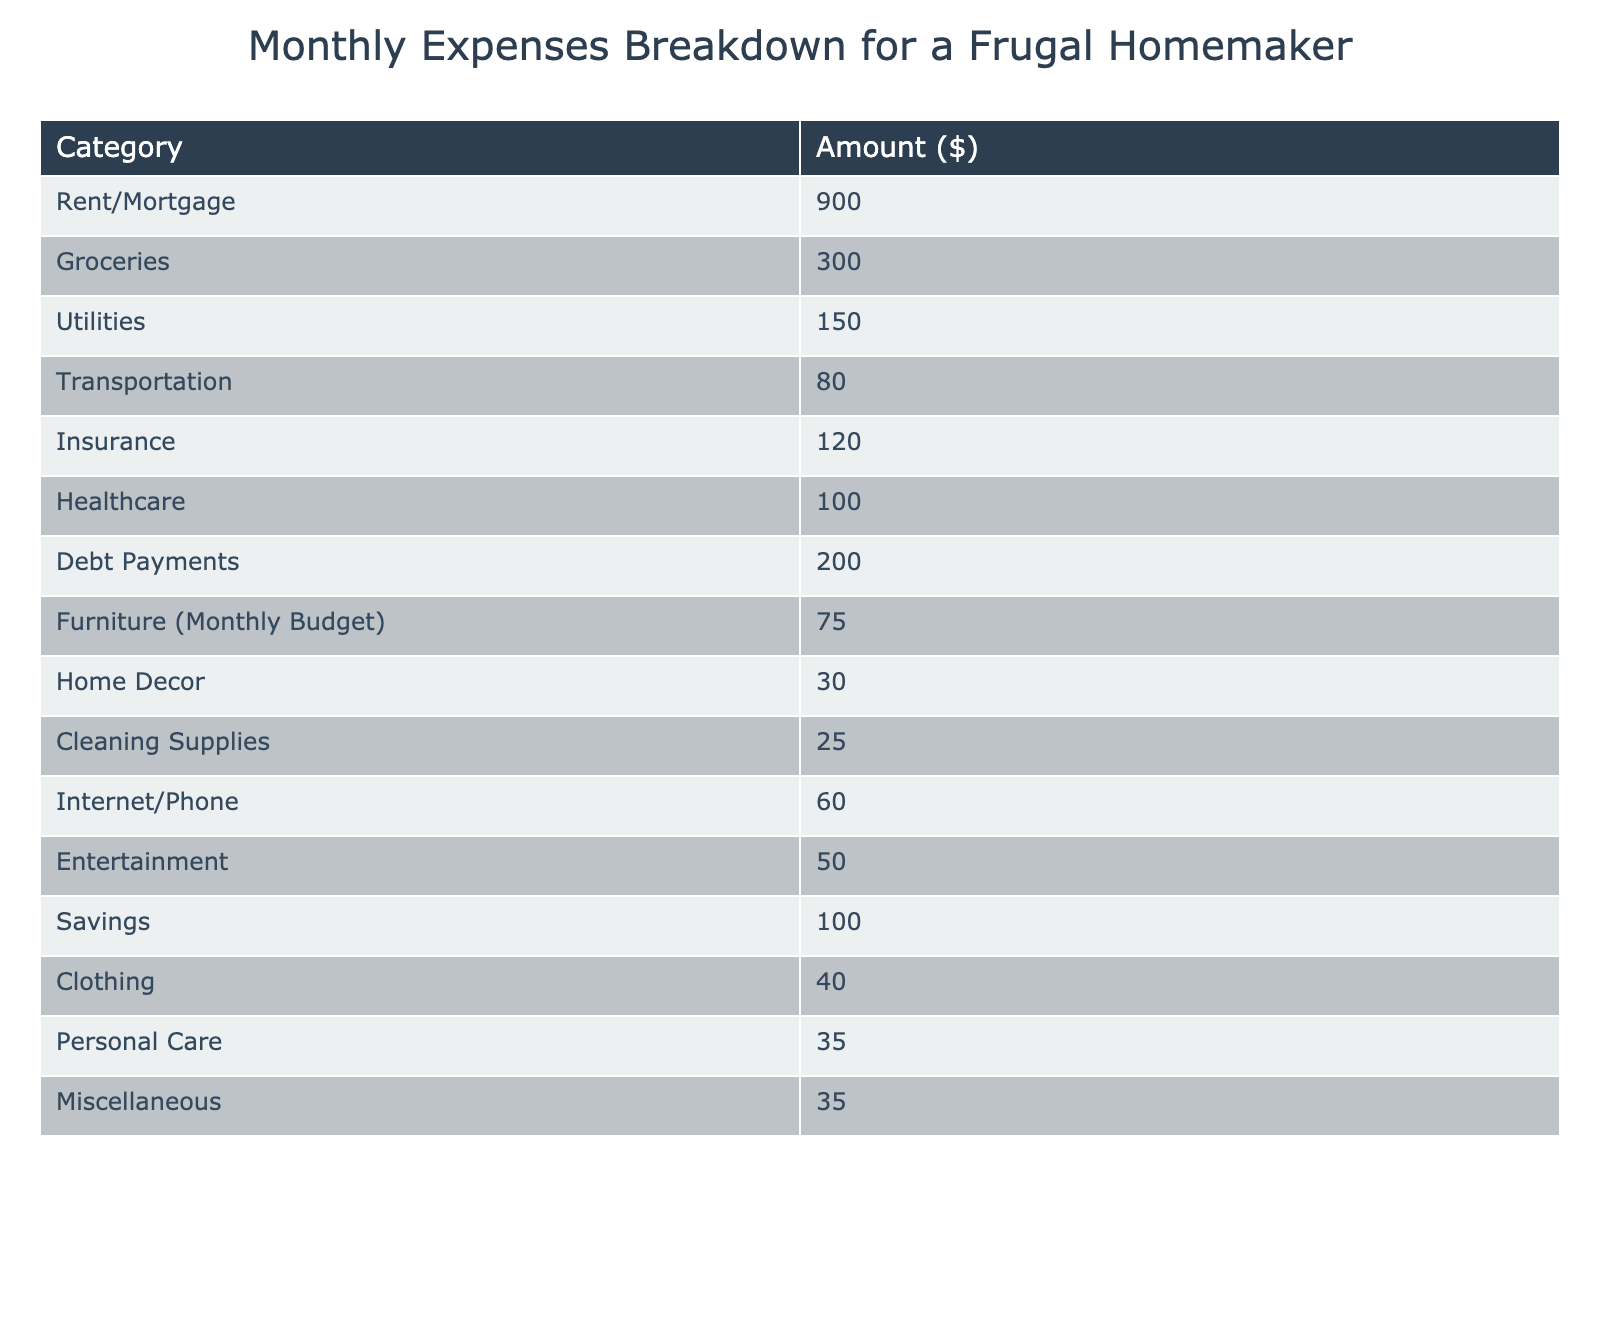What is the monthly budget for furniture? The table specifies a monthly budget of $75 for furniture costs.
Answer: 75 What is the total amount spent on groceries and utilities? To find the total, add the amounts for groceries ($300) and utilities ($150): 300 + 150 = 450.
Answer: 450 How much is allocated for personal care expenses? The table shows that personal care expenses are budgeted at $35.
Answer: 35 Is the monthly rent or mortgage payment higher than the combined costs of internet/phone and cleaning supplies? Rent/Mortgage is $900, and the sum of internet/phone ($60) and cleaning supplies ($25) is 60 + 25 = 85, which is less than 900.
Answer: Yes What percentage of the total monthly expenses is spent on savings? First, sum all expenses: $900 + $300 + $150 + $80 + $120 + $100 + $200 + $75 + $30 + $25 + $60 + $50 + $100 + $40 + $35 + $35 = $1,950. Savings is $100. Then, calculate the percentage: (100/1950) * 100 = 5.13%.
Answer: Approximately 5.13% If the furniture budget were doubled, what would the new budget be? The current furniture budget is $75. Doubling it gives 75 * 2 = $150.
Answer: 150 What are the total expenses for entertainment and home decor? The entertainment amount is $50 and home decor is $30. Adding those gives 50 + 30 = 80.
Answer: 80 Is total debt payment higher than the total of insurance and healthcare costs? Total debt payments are $200. Adding insurance ($120) and healthcare ($100) gives 120 + 100 = 220. Since 200 is less than 220, debt payment is not higher.
Answer: No How much more is spent on rent/mortgage compared to clothing? Rent/mortgage is $900, while clothing costs $40. The difference is 900 - 40 = 860.
Answer: 860 What is the average monthly expense across all categories? The total monthly expenses are $1,950, and there are 15 categories. The average is 1950 / 15 = 130.
Answer: 130 What is the total budget for all cleaning supplies and miscellaneous expenses? Cleaning supplies cost $25 and miscellaneous expenses are $35. The total is 25 + 35 = 60.
Answer: 60 